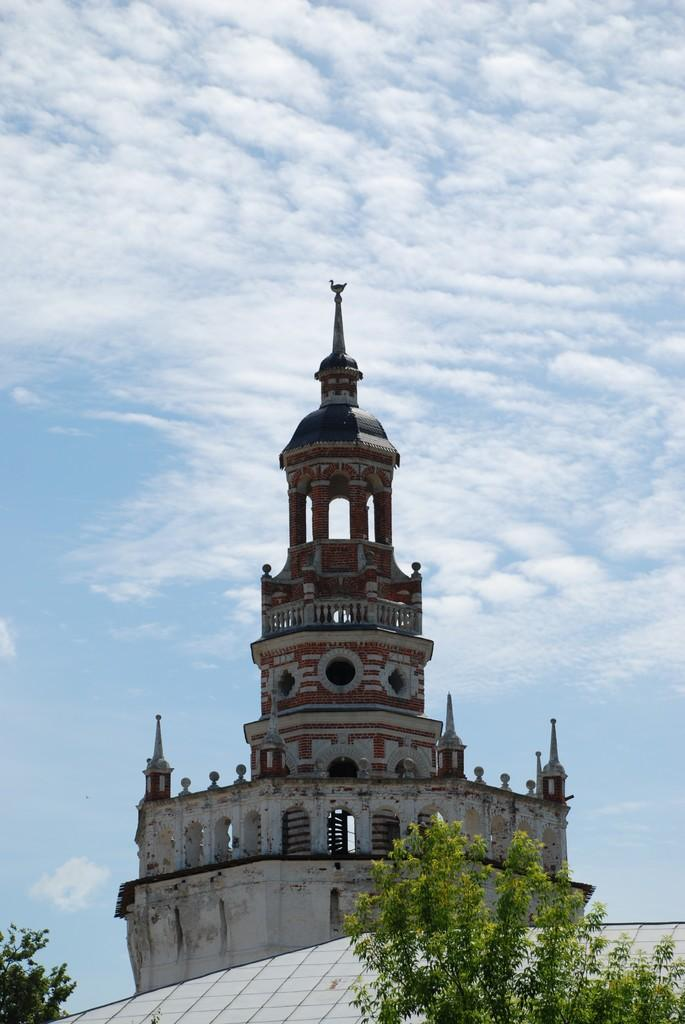What type of vegetation is in front of the building in the image? There are trees in front of the building in the image. Where is the building located in the image? The building is in the middle of the image. What is visible in the background of the image? The sky is visible in the background of the image. What is the condition of the sky in the image? The sky is clear in the image. Can you see any zinc in the image? There is no zinc present in the image. What type of twig is growing on the trees in the image? There is no twig visible in the image; only the trees and the building are present. 